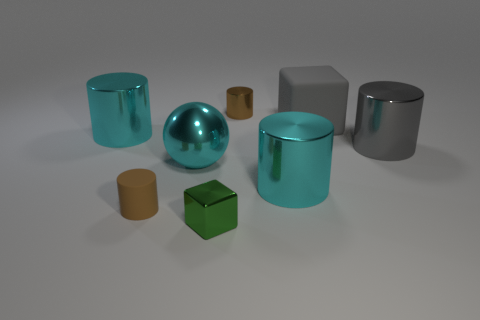Subtract all gray shiny cylinders. How many cylinders are left? 4 Subtract 2 cylinders. How many cylinders are left? 3 Subtract all purple cylinders. Subtract all cyan blocks. How many cylinders are left? 5 Add 1 big green rubber spheres. How many objects exist? 9 Subtract all cubes. How many objects are left? 6 Add 1 large gray rubber things. How many large gray rubber things are left? 2 Add 6 gray metallic cylinders. How many gray metallic cylinders exist? 7 Subtract 0 red spheres. How many objects are left? 8 Subtract all large cyan objects. Subtract all green metal blocks. How many objects are left? 4 